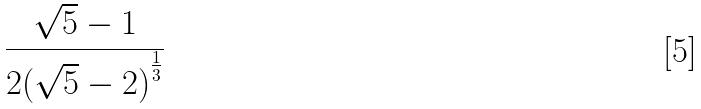Convert formula to latex. <formula><loc_0><loc_0><loc_500><loc_500>\frac { \sqrt { 5 } - 1 } { 2 { ( \sqrt { 5 } - 2 ) } ^ { \frac { 1 } { 3 } } }</formula> 